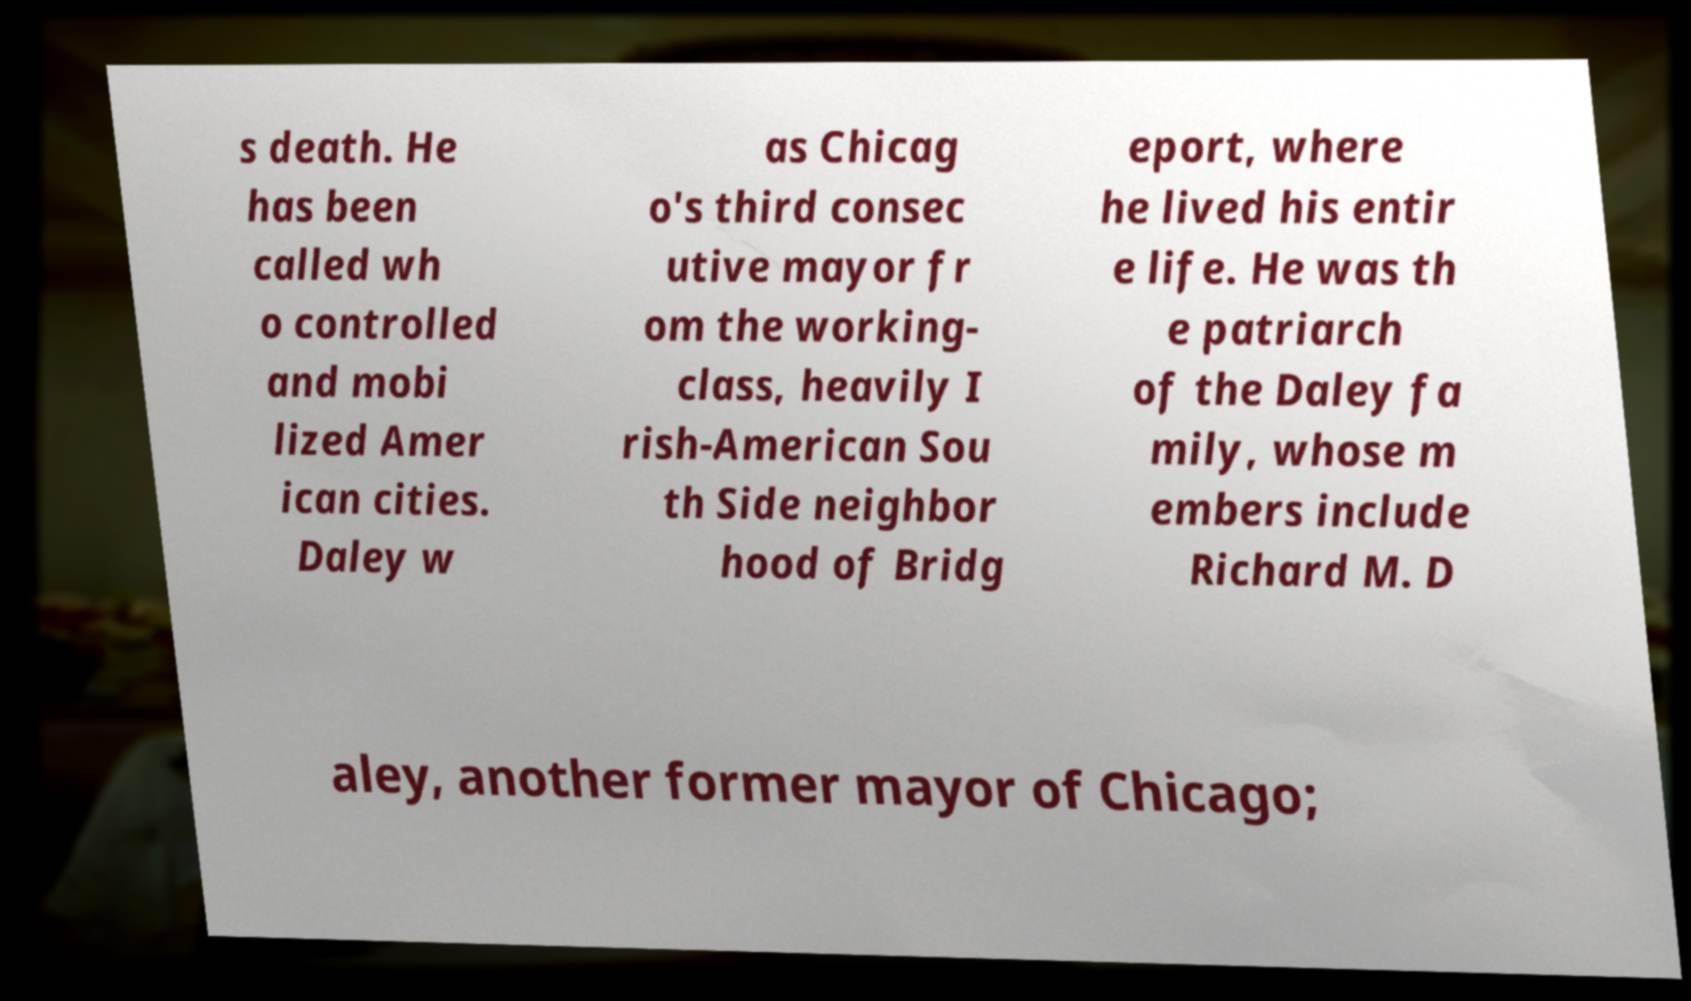For documentation purposes, I need the text within this image transcribed. Could you provide that? s death. He has been called wh o controlled and mobi lized Amer ican cities. Daley w as Chicag o's third consec utive mayor fr om the working- class, heavily I rish-American Sou th Side neighbor hood of Bridg eport, where he lived his entir e life. He was th e patriarch of the Daley fa mily, whose m embers include Richard M. D aley, another former mayor of Chicago; 